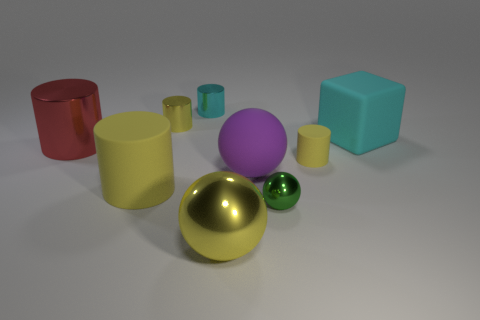Is there any other thing that has the same size as the purple matte sphere?
Offer a very short reply. Yes. There is a big red thing that is the same shape as the tiny yellow rubber thing; what material is it?
Your response must be concise. Metal. The tiny metal object that is in front of the yellow rubber cylinder left of the purple thing is what shape?
Ensure brevity in your answer.  Sphere. Do the tiny yellow cylinder on the right side of the yellow ball and the small green object have the same material?
Provide a succinct answer. No. Is the number of tiny yellow shiny things that are to the right of the tiny yellow rubber cylinder the same as the number of cyan blocks behind the tiny cyan cylinder?
Your response must be concise. Yes. There is a small object that is the same color as the matte block; what material is it?
Make the answer very short. Metal. What number of yellow cylinders are in front of the yellow thing behind the big red object?
Give a very brief answer. 2. Is the color of the matte cylinder on the right side of the tiny cyan metal cylinder the same as the large object that is to the right of the tiny green object?
Keep it short and to the point. No. What is the material of the red thing that is the same size as the matte block?
Offer a very short reply. Metal. What is the shape of the yellow rubber thing to the right of the yellow metallic object that is behind the small cylinder in front of the yellow metallic cylinder?
Make the answer very short. Cylinder. 